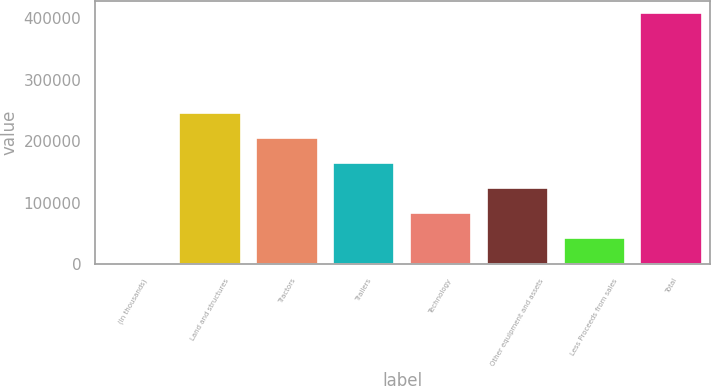Convert chart to OTSL. <chart><loc_0><loc_0><loc_500><loc_500><bar_chart><fcel>(In thousands)<fcel>Land and structures<fcel>Tractors<fcel>Trailers<fcel>Technology<fcel>Other equipment and assets<fcel>Less Proceeds from sales<fcel>Total<nl><fcel>2016<fcel>245246<fcel>204708<fcel>164170<fcel>83092.8<fcel>123631<fcel>42554.4<fcel>407400<nl></chart> 